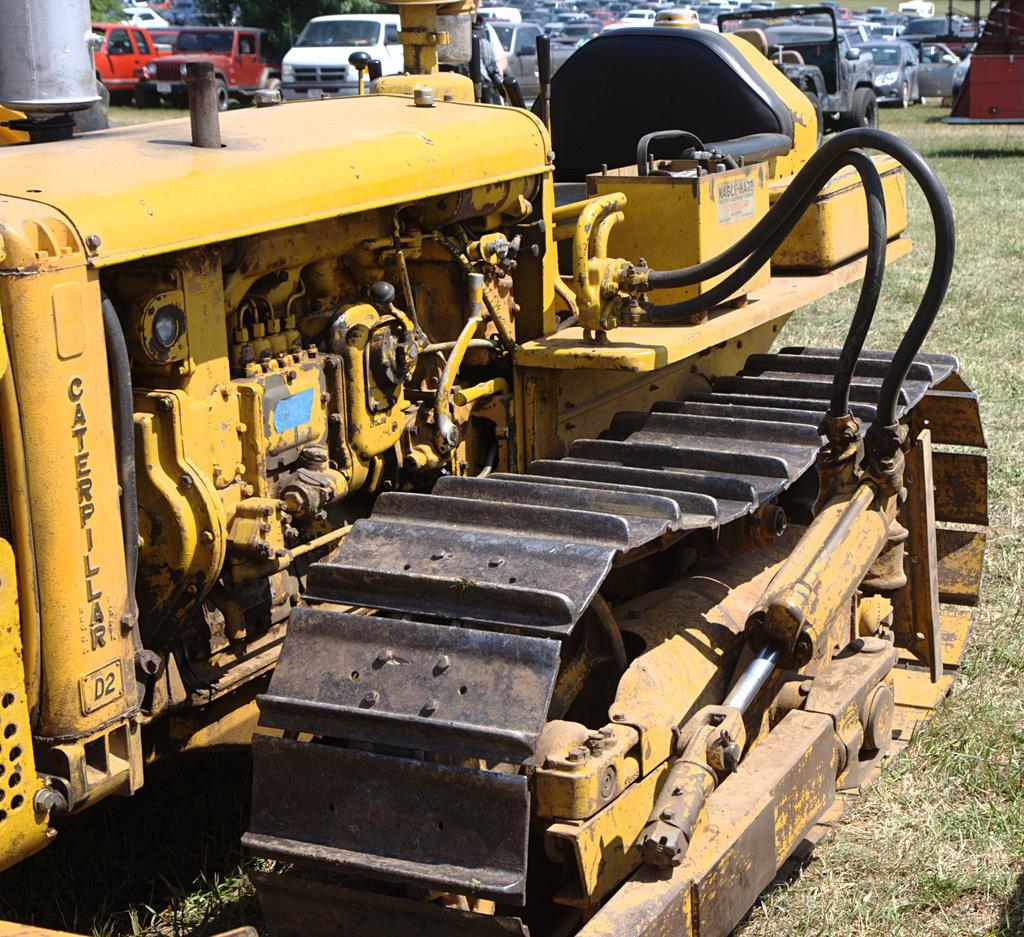What is the main setting of the image? There is an open grass ground in the image. What can be seen on the grass ground? There are vehicles on the grass ground. What type of natural elements are visible in the image? There are trees visible in the top left side of the image. Where is the test being conducted in the image? There is no test being conducted in the image; it features an open grass ground with vehicles and trees. Can you describe the bed in the image? There is no bed present in the image. 